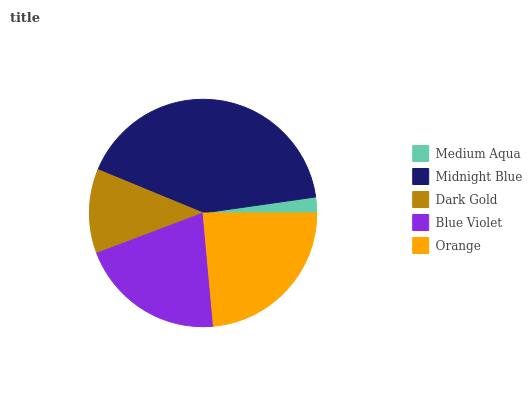Is Medium Aqua the minimum?
Answer yes or no. Yes. Is Midnight Blue the maximum?
Answer yes or no. Yes. Is Dark Gold the minimum?
Answer yes or no. No. Is Dark Gold the maximum?
Answer yes or no. No. Is Midnight Blue greater than Dark Gold?
Answer yes or no. Yes. Is Dark Gold less than Midnight Blue?
Answer yes or no. Yes. Is Dark Gold greater than Midnight Blue?
Answer yes or no. No. Is Midnight Blue less than Dark Gold?
Answer yes or no. No. Is Blue Violet the high median?
Answer yes or no. Yes. Is Blue Violet the low median?
Answer yes or no. Yes. Is Midnight Blue the high median?
Answer yes or no. No. Is Midnight Blue the low median?
Answer yes or no. No. 